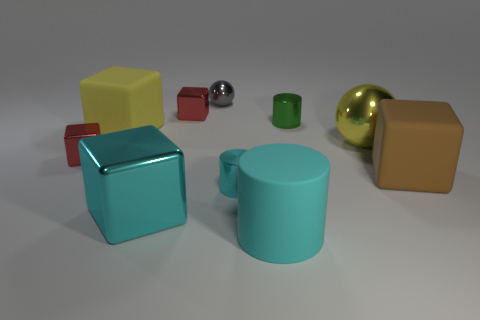Can you describe the objects in the image in terms of their colors and shapes? Certainly! The image displays a collection of geometric objects with differing colors and shapes. There's a large yellow cube, a large tan rectangle, a bright blue cube, and a teal cylinder. Additionally, there are smaller objects: a red cube, a small green cube, a silver sphere, and a larger golden sphere. 